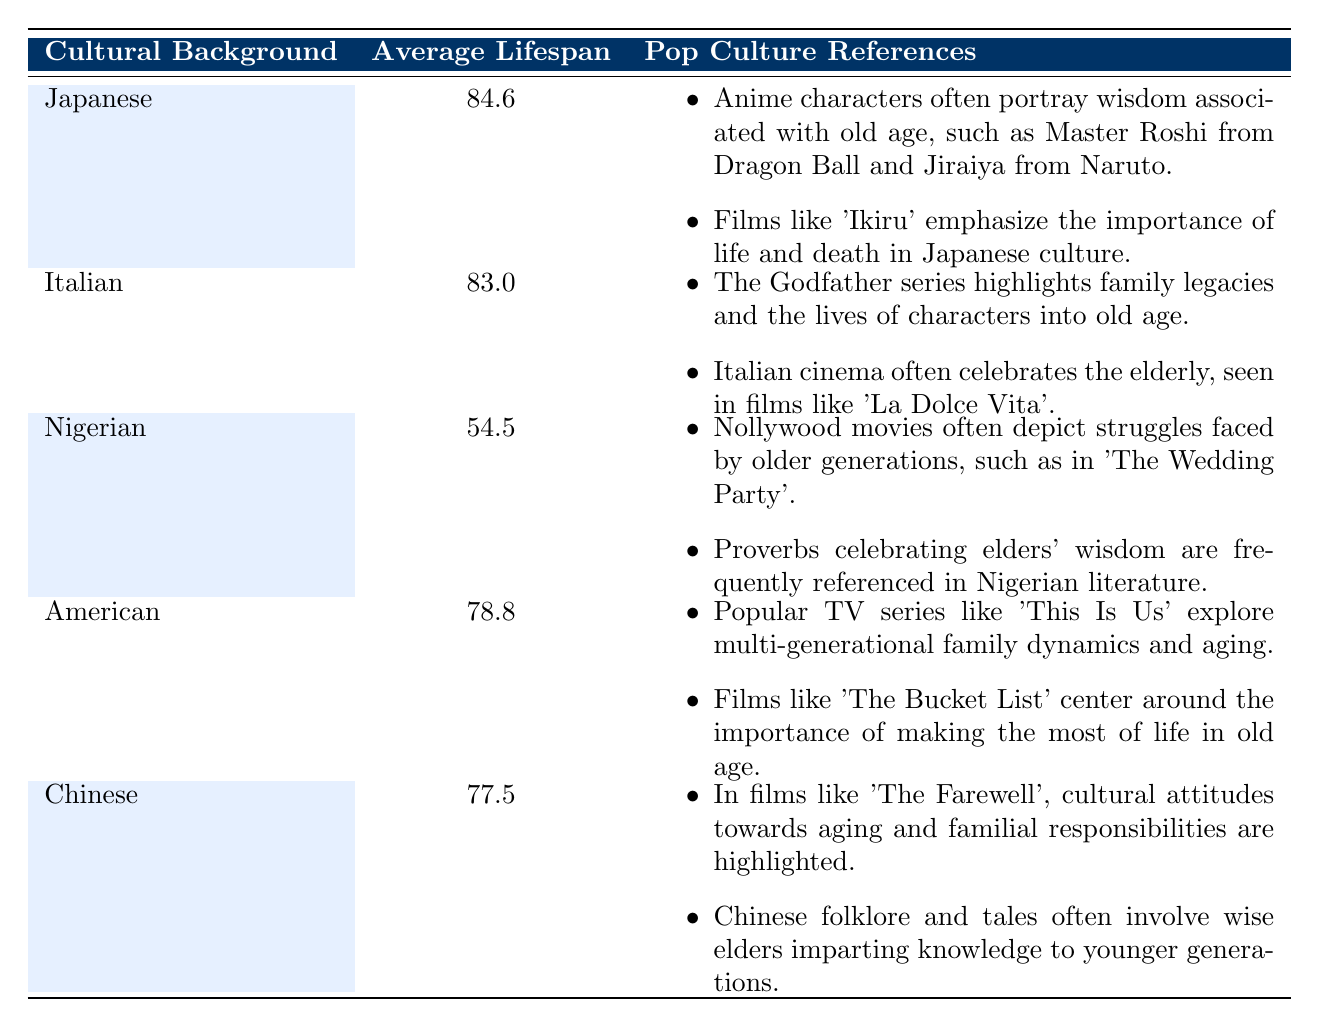What is the average lifespan for Japanese individuals? The table shows the average lifespan for individuals of Japanese cultural background as 84.6 years.
Answer: 84.6 How does the average lifespan of Nigerians compare to that of Italians? The average lifespan for Nigerians is 54.5 years while for Italians it is 83.0 years. To find the difference, subtract 54.5 from 83.0, resulting in 28.5 years.
Answer: 28.5 Which cultural background has the highest average lifespan? The table indicates that Japanese individuals have the highest average lifespan at 84.6 years.
Answer: Japanese Is it true that the average lifespan for Americans is greater than that of Chinese individuals? Yes, the table lists the average lifespan for Americans as 78.8 years and for Chinese as 77.5 years. Since 78.8 is greater than 77.5, the statement is true.
Answer: Yes If we consider the average lifespans for all listed cultural backgrounds, what is the average lifespan for these five groups? To calculate the average lifespan: (84.6 + 83.0 + 54.5 + 78.8 + 77.5) = 378.4 total years. There are 5 groups, so divide by 5, giving 378.4 / 5 = 75.68.
Answer: 75.68 What is the main focus of pop culture references regarding elders in Nigerian culture? The pop culture references highlight struggles faced by older generations, particularly in Nollywood movies and emphasize wisdom through proverbs.
Answer: Struggles and wisdom How do the average lifespans of Italians and Chinese compare? Italians have an average lifespan of 83.0 years, while Chinese individuals have 77.5 years. To compare, subtract 77.5 from 83.0, which gives a difference of 5.5 years, indicating Italians live longer on average.
Answer: 5.5 Is there a cultural background where the average lifespan is below 60 years? Yes, the Nigerian average lifespan is 54.5 years, which is below 60 years.
Answer: Yes What is the significance of pop culture references in American films regarding aging? American pop culture often emphasizes the importance of making the most of life in old age, as shown in films like 'The Bucket List', highlighting personal fulfillment.
Answer: Making the most of life 